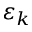<formula> <loc_0><loc_0><loc_500><loc_500>\varepsilon _ { k }</formula> 